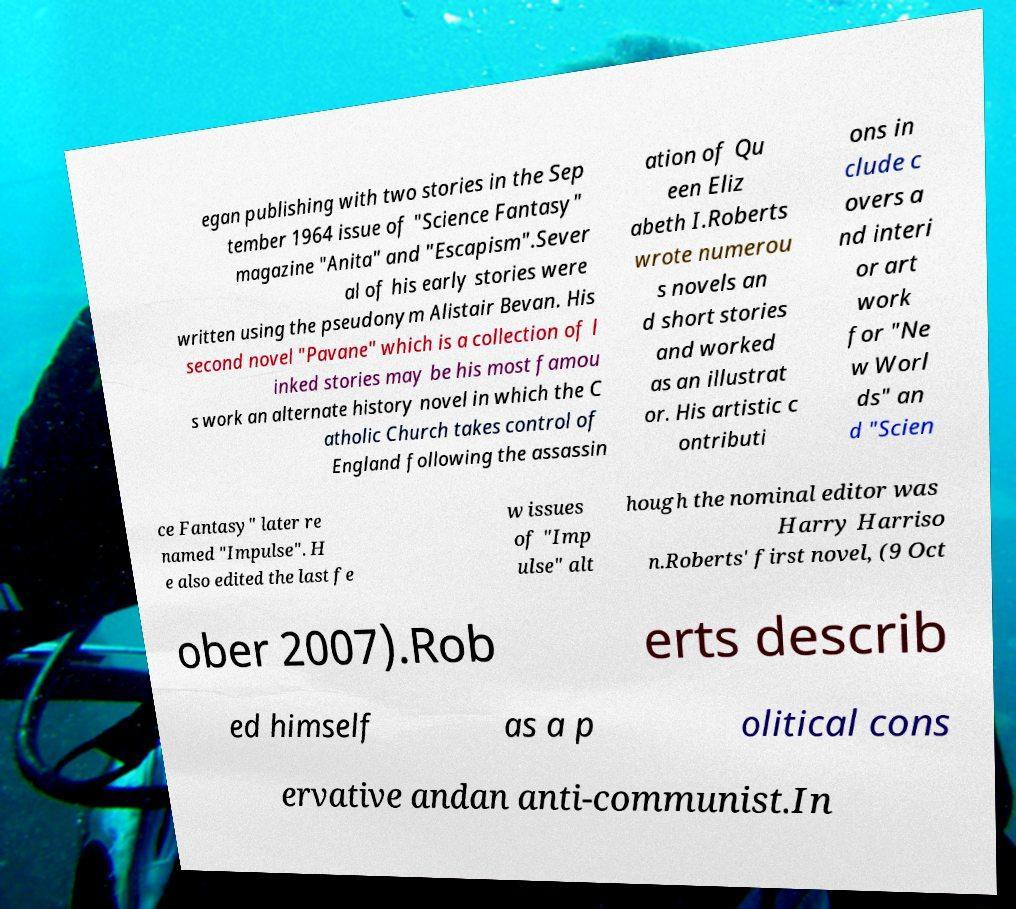Please identify and transcribe the text found in this image. egan publishing with two stories in the Sep tember 1964 issue of "Science Fantasy" magazine "Anita" and "Escapism".Sever al of his early stories were written using the pseudonym Alistair Bevan. His second novel "Pavane" which is a collection of l inked stories may be his most famou s work an alternate history novel in which the C atholic Church takes control of England following the assassin ation of Qu een Eliz abeth I.Roberts wrote numerou s novels an d short stories and worked as an illustrat or. His artistic c ontributi ons in clude c overs a nd interi or art work for "Ne w Worl ds" an d "Scien ce Fantasy" later re named "Impulse". H e also edited the last fe w issues of "Imp ulse" alt hough the nominal editor was Harry Harriso n.Roberts' first novel, (9 Oct ober 2007).Rob erts describ ed himself as a p olitical cons ervative andan anti-communist.In 